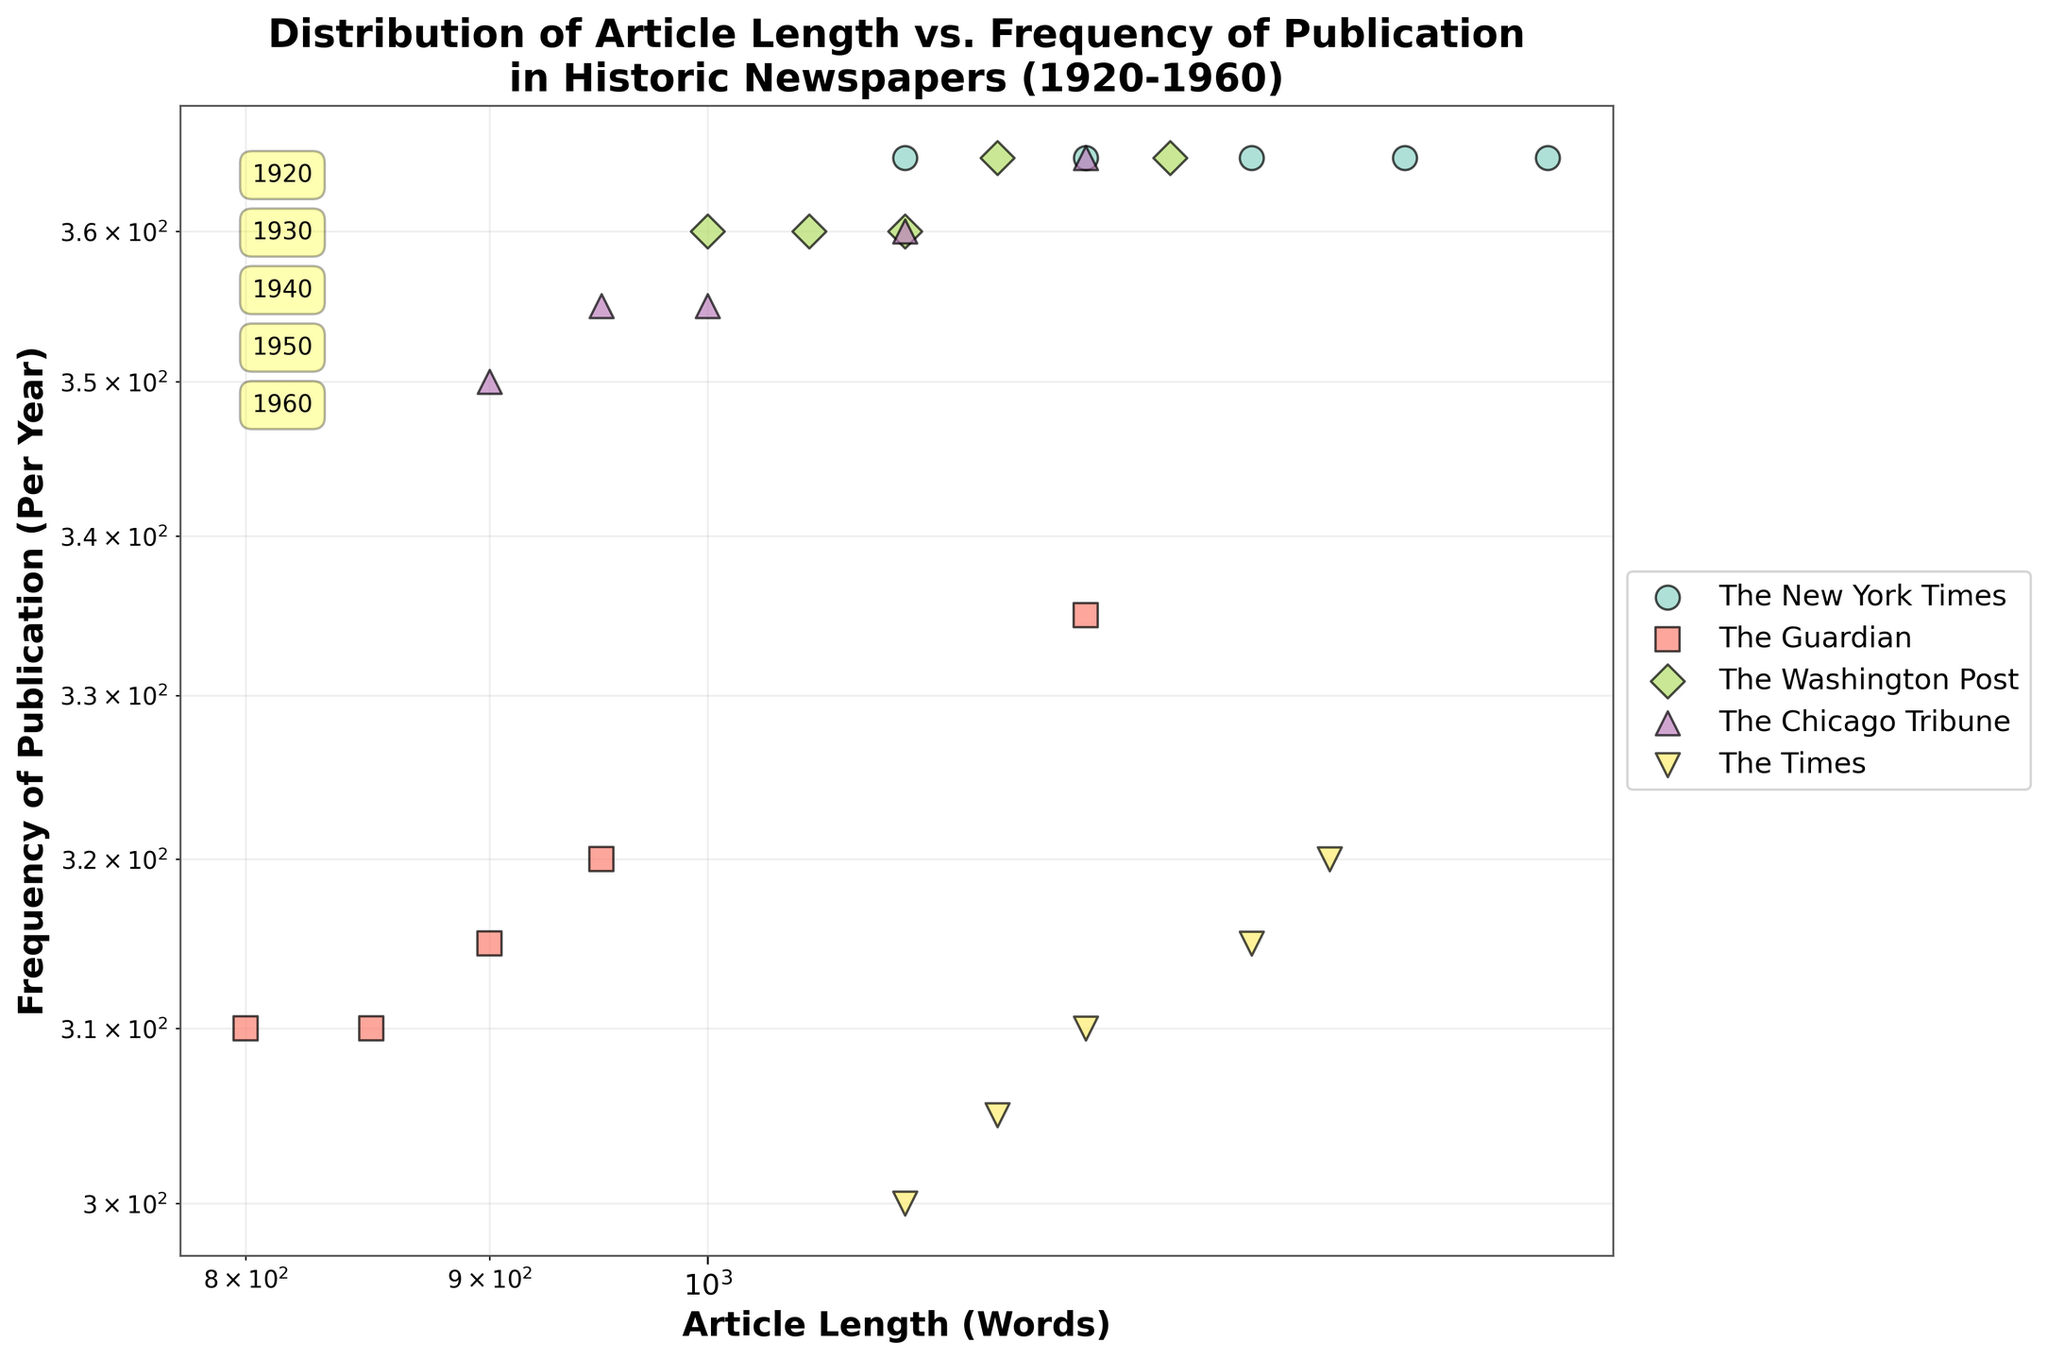What is the title of the plot? The title of the plot is usually located at the top center of the figure. In this case, it should be given in the data description.
Answer: Distribution of Article Length vs. Frequency of Publication in Historic Newspapers (1920-1960) How many unique newspapers are represented in the plot? Each newspaper is represented by a unique color and marker style. By counting the different colors and markers in the legend, we can determine the number of unique newspapers.
Answer: 5 Which newspaper has the highest publication frequency in 1960? Locate the data points for 1960 and identify which newspaper corresponds to the highest y-values (publication frequency) in that year.
Answer: The New York Times What trend can be observed in article length over the years for The Guardian? By connecting the data points for The Guardian from 1920 to 1960, we can observe whether the article lengths generally increase, decrease, or remain the same over time.
Answer: Increasing Which newspaper has the most consistent publication frequency across all years? Examine each newspaper's data points for fluctuations in y-values (publication frequency). Consistency implies minimal variations over the years.
Answer: The Washington Post What is the relationship between article length and publication frequency for The Times? By observing the data points for The Times, analyze whether an increase in article length corresponds to an increase, decrease, or no change in publication frequency.
Answer: Positive correlation How does the article length of The Chicago Tribune in 1940 compare to that of The Washington Post in 1940? Locate the data points for both newspapers in 1940 and compare their x-values (article length).
Answer: The Chicago Tribune is shorter Which newspaper had the shortest articles in 1950? Find the data points for 1950 and identify the newspaper with the smallest x-value (article length).
Answer: The Guardian What overall pattern can be observed regarding the relationship between article length and publication frequency across all newspapers? By examining the scatter plot as a whole, determine whether there is a general trend or correlation between the two variables across all newspapers.
Answer: No clear pattern 